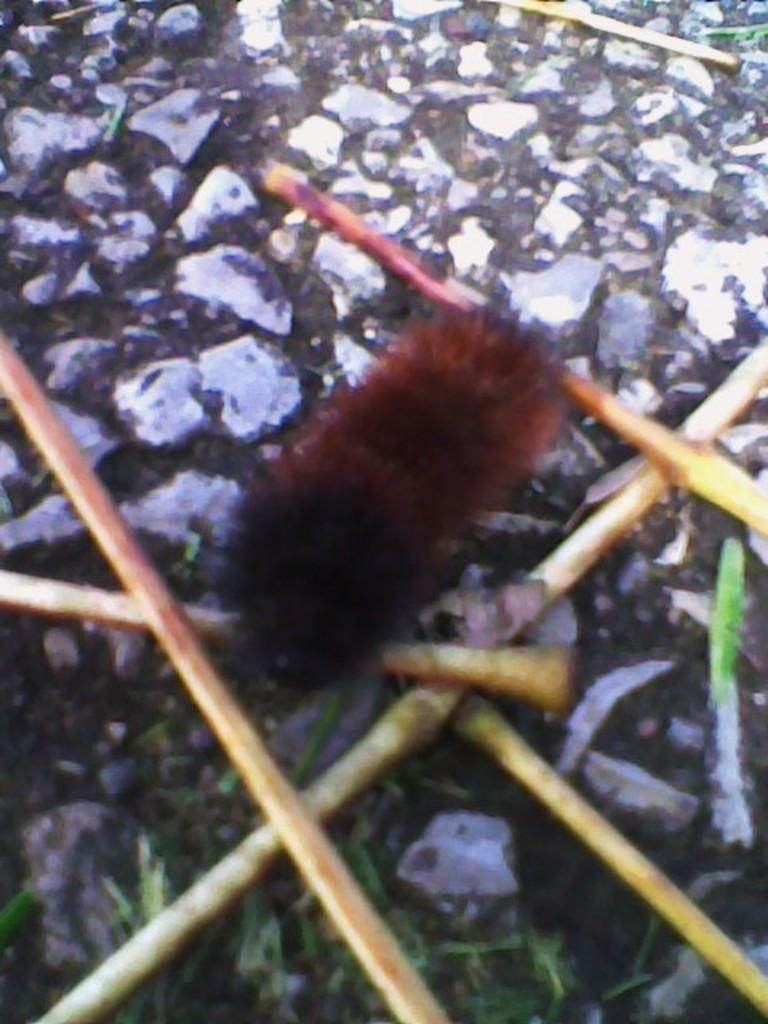What type of creature can be seen in the image? There is an insect in the image. Where is the insect located? The insect is on a surface. How many children are playing with the insect in the image? There are no children present in the image, and the insect is not being played with. 